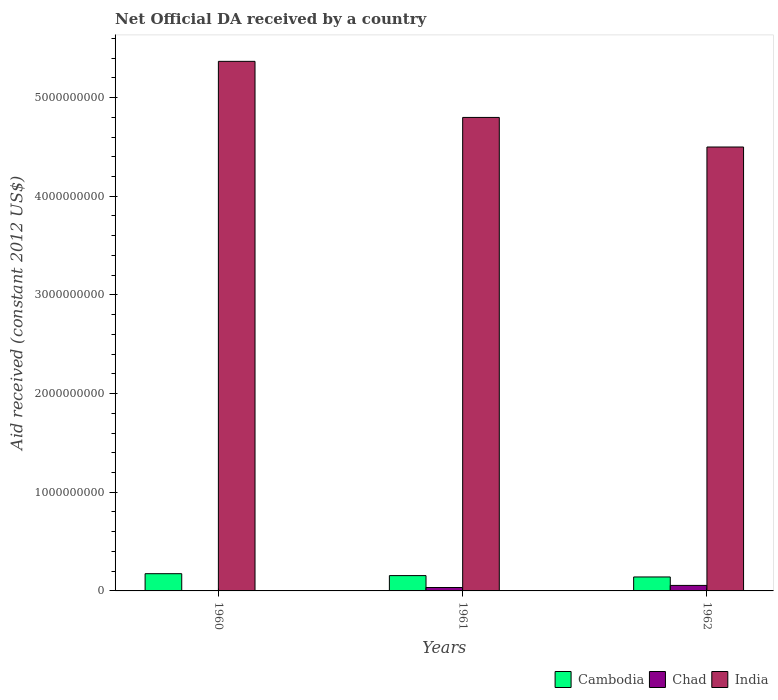How many groups of bars are there?
Provide a short and direct response. 3. Are the number of bars on each tick of the X-axis equal?
Your answer should be compact. Yes. How many bars are there on the 2nd tick from the left?
Offer a terse response. 3. How many bars are there on the 3rd tick from the right?
Your response must be concise. 3. In how many cases, is the number of bars for a given year not equal to the number of legend labels?
Offer a terse response. 0. What is the net official development assistance aid received in Chad in 1962?
Offer a very short reply. 5.57e+07. Across all years, what is the maximum net official development assistance aid received in Cambodia?
Offer a terse response. 1.75e+08. Across all years, what is the minimum net official development assistance aid received in India?
Make the answer very short. 4.50e+09. What is the total net official development assistance aid received in India in the graph?
Your answer should be compact. 1.47e+1. What is the difference between the net official development assistance aid received in India in 1961 and that in 1962?
Give a very brief answer. 3.00e+08. What is the difference between the net official development assistance aid received in Chad in 1962 and the net official development assistance aid received in Cambodia in 1961?
Your answer should be compact. -9.95e+07. What is the average net official development assistance aid received in India per year?
Offer a terse response. 4.89e+09. In the year 1960, what is the difference between the net official development assistance aid received in Cambodia and net official development assistance aid received in India?
Keep it short and to the point. -5.19e+09. In how many years, is the net official development assistance aid received in India greater than 4400000000 US$?
Provide a succinct answer. 3. What is the ratio of the net official development assistance aid received in India in 1960 to that in 1962?
Make the answer very short. 1.19. Is the net official development assistance aid received in Chad in 1960 less than that in 1962?
Ensure brevity in your answer.  Yes. What is the difference between the highest and the second highest net official development assistance aid received in Cambodia?
Provide a succinct answer. 1.93e+07. What is the difference between the highest and the lowest net official development assistance aid received in Chad?
Offer a terse response. 5.54e+07. In how many years, is the net official development assistance aid received in Chad greater than the average net official development assistance aid received in Chad taken over all years?
Give a very brief answer. 2. What does the 1st bar from the left in 1960 represents?
Your answer should be very brief. Cambodia. What does the 3rd bar from the right in 1960 represents?
Offer a terse response. Cambodia. How many years are there in the graph?
Your answer should be compact. 3. Are the values on the major ticks of Y-axis written in scientific E-notation?
Your answer should be compact. No. Does the graph contain any zero values?
Provide a short and direct response. No. Where does the legend appear in the graph?
Offer a terse response. Bottom right. How many legend labels are there?
Provide a short and direct response. 3. What is the title of the graph?
Your answer should be very brief. Net Official DA received by a country. What is the label or title of the Y-axis?
Offer a terse response. Aid received (constant 2012 US$). What is the Aid received (constant 2012 US$) of Cambodia in 1960?
Your answer should be compact. 1.75e+08. What is the Aid received (constant 2012 US$) of Chad in 1960?
Your answer should be very brief. 3.00e+05. What is the Aid received (constant 2012 US$) in India in 1960?
Ensure brevity in your answer.  5.37e+09. What is the Aid received (constant 2012 US$) of Cambodia in 1961?
Your answer should be very brief. 1.55e+08. What is the Aid received (constant 2012 US$) of Chad in 1961?
Give a very brief answer. 3.45e+07. What is the Aid received (constant 2012 US$) in India in 1961?
Your answer should be compact. 4.80e+09. What is the Aid received (constant 2012 US$) of Cambodia in 1962?
Your response must be concise. 1.42e+08. What is the Aid received (constant 2012 US$) of Chad in 1962?
Give a very brief answer. 5.57e+07. What is the Aid received (constant 2012 US$) in India in 1962?
Offer a terse response. 4.50e+09. Across all years, what is the maximum Aid received (constant 2012 US$) in Cambodia?
Keep it short and to the point. 1.75e+08. Across all years, what is the maximum Aid received (constant 2012 US$) in Chad?
Keep it short and to the point. 5.57e+07. Across all years, what is the maximum Aid received (constant 2012 US$) in India?
Ensure brevity in your answer.  5.37e+09. Across all years, what is the minimum Aid received (constant 2012 US$) of Cambodia?
Ensure brevity in your answer.  1.42e+08. Across all years, what is the minimum Aid received (constant 2012 US$) in Chad?
Keep it short and to the point. 3.00e+05. Across all years, what is the minimum Aid received (constant 2012 US$) of India?
Provide a short and direct response. 4.50e+09. What is the total Aid received (constant 2012 US$) in Cambodia in the graph?
Your answer should be very brief. 4.71e+08. What is the total Aid received (constant 2012 US$) of Chad in the graph?
Offer a terse response. 9.06e+07. What is the total Aid received (constant 2012 US$) in India in the graph?
Offer a very short reply. 1.47e+1. What is the difference between the Aid received (constant 2012 US$) in Cambodia in 1960 and that in 1961?
Offer a very short reply. 1.93e+07. What is the difference between the Aid received (constant 2012 US$) in Chad in 1960 and that in 1961?
Keep it short and to the point. -3.42e+07. What is the difference between the Aid received (constant 2012 US$) of India in 1960 and that in 1961?
Keep it short and to the point. 5.68e+08. What is the difference between the Aid received (constant 2012 US$) in Cambodia in 1960 and that in 1962?
Ensure brevity in your answer.  3.30e+07. What is the difference between the Aid received (constant 2012 US$) in Chad in 1960 and that in 1962?
Keep it short and to the point. -5.54e+07. What is the difference between the Aid received (constant 2012 US$) in India in 1960 and that in 1962?
Your response must be concise. 8.68e+08. What is the difference between the Aid received (constant 2012 US$) of Cambodia in 1961 and that in 1962?
Offer a terse response. 1.37e+07. What is the difference between the Aid received (constant 2012 US$) in Chad in 1961 and that in 1962?
Your answer should be very brief. -2.12e+07. What is the difference between the Aid received (constant 2012 US$) in India in 1961 and that in 1962?
Provide a succinct answer. 3.00e+08. What is the difference between the Aid received (constant 2012 US$) of Cambodia in 1960 and the Aid received (constant 2012 US$) of Chad in 1961?
Give a very brief answer. 1.40e+08. What is the difference between the Aid received (constant 2012 US$) in Cambodia in 1960 and the Aid received (constant 2012 US$) in India in 1961?
Provide a short and direct response. -4.62e+09. What is the difference between the Aid received (constant 2012 US$) of Chad in 1960 and the Aid received (constant 2012 US$) of India in 1961?
Your answer should be very brief. -4.80e+09. What is the difference between the Aid received (constant 2012 US$) of Cambodia in 1960 and the Aid received (constant 2012 US$) of Chad in 1962?
Offer a very short reply. 1.19e+08. What is the difference between the Aid received (constant 2012 US$) of Cambodia in 1960 and the Aid received (constant 2012 US$) of India in 1962?
Offer a terse response. -4.32e+09. What is the difference between the Aid received (constant 2012 US$) of Chad in 1960 and the Aid received (constant 2012 US$) of India in 1962?
Your answer should be very brief. -4.50e+09. What is the difference between the Aid received (constant 2012 US$) of Cambodia in 1961 and the Aid received (constant 2012 US$) of Chad in 1962?
Make the answer very short. 9.95e+07. What is the difference between the Aid received (constant 2012 US$) in Cambodia in 1961 and the Aid received (constant 2012 US$) in India in 1962?
Your response must be concise. -4.34e+09. What is the difference between the Aid received (constant 2012 US$) in Chad in 1961 and the Aid received (constant 2012 US$) in India in 1962?
Give a very brief answer. -4.46e+09. What is the average Aid received (constant 2012 US$) in Cambodia per year?
Provide a succinct answer. 1.57e+08. What is the average Aid received (constant 2012 US$) in Chad per year?
Offer a very short reply. 3.02e+07. What is the average Aid received (constant 2012 US$) in India per year?
Provide a short and direct response. 4.89e+09. In the year 1960, what is the difference between the Aid received (constant 2012 US$) in Cambodia and Aid received (constant 2012 US$) in Chad?
Your response must be concise. 1.74e+08. In the year 1960, what is the difference between the Aid received (constant 2012 US$) in Cambodia and Aid received (constant 2012 US$) in India?
Offer a terse response. -5.19e+09. In the year 1960, what is the difference between the Aid received (constant 2012 US$) of Chad and Aid received (constant 2012 US$) of India?
Make the answer very short. -5.37e+09. In the year 1961, what is the difference between the Aid received (constant 2012 US$) in Cambodia and Aid received (constant 2012 US$) in Chad?
Offer a terse response. 1.21e+08. In the year 1961, what is the difference between the Aid received (constant 2012 US$) of Cambodia and Aid received (constant 2012 US$) of India?
Provide a succinct answer. -4.64e+09. In the year 1961, what is the difference between the Aid received (constant 2012 US$) of Chad and Aid received (constant 2012 US$) of India?
Offer a terse response. -4.76e+09. In the year 1962, what is the difference between the Aid received (constant 2012 US$) in Cambodia and Aid received (constant 2012 US$) in Chad?
Provide a short and direct response. 8.58e+07. In the year 1962, what is the difference between the Aid received (constant 2012 US$) in Cambodia and Aid received (constant 2012 US$) in India?
Keep it short and to the point. -4.36e+09. In the year 1962, what is the difference between the Aid received (constant 2012 US$) in Chad and Aid received (constant 2012 US$) in India?
Keep it short and to the point. -4.44e+09. What is the ratio of the Aid received (constant 2012 US$) of Cambodia in 1960 to that in 1961?
Your answer should be compact. 1.12. What is the ratio of the Aid received (constant 2012 US$) of Chad in 1960 to that in 1961?
Give a very brief answer. 0.01. What is the ratio of the Aid received (constant 2012 US$) in India in 1960 to that in 1961?
Make the answer very short. 1.12. What is the ratio of the Aid received (constant 2012 US$) of Cambodia in 1960 to that in 1962?
Your answer should be compact. 1.23. What is the ratio of the Aid received (constant 2012 US$) in Chad in 1960 to that in 1962?
Keep it short and to the point. 0.01. What is the ratio of the Aid received (constant 2012 US$) of India in 1960 to that in 1962?
Keep it short and to the point. 1.19. What is the ratio of the Aid received (constant 2012 US$) of Cambodia in 1961 to that in 1962?
Provide a short and direct response. 1.1. What is the ratio of the Aid received (constant 2012 US$) of Chad in 1961 to that in 1962?
Your answer should be compact. 0.62. What is the ratio of the Aid received (constant 2012 US$) in India in 1961 to that in 1962?
Your answer should be compact. 1.07. What is the difference between the highest and the second highest Aid received (constant 2012 US$) in Cambodia?
Provide a short and direct response. 1.93e+07. What is the difference between the highest and the second highest Aid received (constant 2012 US$) of Chad?
Give a very brief answer. 2.12e+07. What is the difference between the highest and the second highest Aid received (constant 2012 US$) of India?
Provide a succinct answer. 5.68e+08. What is the difference between the highest and the lowest Aid received (constant 2012 US$) in Cambodia?
Your answer should be compact. 3.30e+07. What is the difference between the highest and the lowest Aid received (constant 2012 US$) in Chad?
Give a very brief answer. 5.54e+07. What is the difference between the highest and the lowest Aid received (constant 2012 US$) in India?
Make the answer very short. 8.68e+08. 